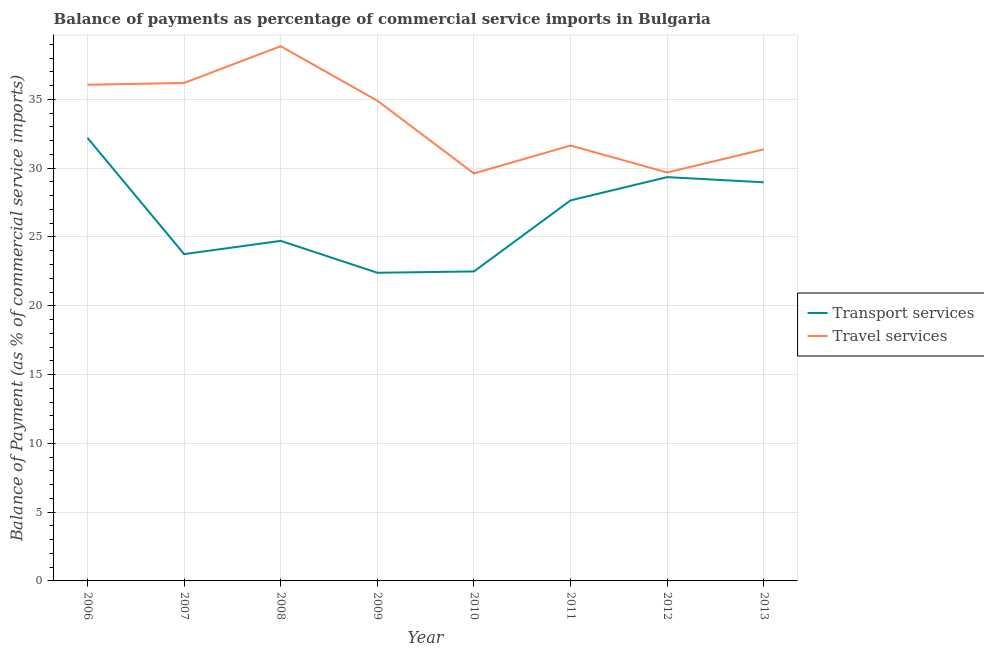How many different coloured lines are there?
Provide a succinct answer. 2. Does the line corresponding to balance of payments of transport services intersect with the line corresponding to balance of payments of travel services?
Your answer should be very brief. No. Is the number of lines equal to the number of legend labels?
Keep it short and to the point. Yes. What is the balance of payments of travel services in 2007?
Make the answer very short. 36.2. Across all years, what is the maximum balance of payments of travel services?
Your answer should be compact. 38.87. Across all years, what is the minimum balance of payments of transport services?
Make the answer very short. 22.4. What is the total balance of payments of travel services in the graph?
Give a very brief answer. 268.36. What is the difference between the balance of payments of travel services in 2007 and that in 2009?
Your answer should be very brief. 1.29. What is the difference between the balance of payments of travel services in 2012 and the balance of payments of transport services in 2006?
Your response must be concise. -2.51. What is the average balance of payments of travel services per year?
Your answer should be very brief. 33.55. In the year 2006, what is the difference between the balance of payments of transport services and balance of payments of travel services?
Your answer should be compact. -3.86. What is the ratio of the balance of payments of travel services in 2006 to that in 2012?
Offer a very short reply. 1.21. Is the balance of payments of travel services in 2007 less than that in 2009?
Provide a short and direct response. No. What is the difference between the highest and the second highest balance of payments of transport services?
Provide a short and direct response. 2.85. What is the difference between the highest and the lowest balance of payments of transport services?
Offer a very short reply. 9.8. Is the sum of the balance of payments of transport services in 2010 and 2012 greater than the maximum balance of payments of travel services across all years?
Keep it short and to the point. Yes. Does the balance of payments of travel services monotonically increase over the years?
Provide a short and direct response. No. How many years are there in the graph?
Your answer should be compact. 8. Are the values on the major ticks of Y-axis written in scientific E-notation?
Your answer should be compact. No. Where does the legend appear in the graph?
Your answer should be very brief. Center right. How are the legend labels stacked?
Your answer should be very brief. Vertical. What is the title of the graph?
Make the answer very short. Balance of payments as percentage of commercial service imports in Bulgaria. What is the label or title of the X-axis?
Your answer should be compact. Year. What is the label or title of the Y-axis?
Your answer should be very brief. Balance of Payment (as % of commercial service imports). What is the Balance of Payment (as % of commercial service imports) in Transport services in 2006?
Give a very brief answer. 32.2. What is the Balance of Payment (as % of commercial service imports) of Travel services in 2006?
Provide a short and direct response. 36.06. What is the Balance of Payment (as % of commercial service imports) of Transport services in 2007?
Your answer should be very brief. 23.75. What is the Balance of Payment (as % of commercial service imports) in Travel services in 2007?
Your response must be concise. 36.2. What is the Balance of Payment (as % of commercial service imports) in Transport services in 2008?
Provide a succinct answer. 24.72. What is the Balance of Payment (as % of commercial service imports) in Travel services in 2008?
Your answer should be very brief. 38.87. What is the Balance of Payment (as % of commercial service imports) of Transport services in 2009?
Offer a very short reply. 22.4. What is the Balance of Payment (as % of commercial service imports) in Travel services in 2009?
Your response must be concise. 34.91. What is the Balance of Payment (as % of commercial service imports) in Transport services in 2010?
Your answer should be very brief. 22.5. What is the Balance of Payment (as % of commercial service imports) of Travel services in 2010?
Your response must be concise. 29.62. What is the Balance of Payment (as % of commercial service imports) in Transport services in 2011?
Make the answer very short. 27.66. What is the Balance of Payment (as % of commercial service imports) in Travel services in 2011?
Your answer should be very brief. 31.65. What is the Balance of Payment (as % of commercial service imports) in Transport services in 2012?
Offer a terse response. 29.35. What is the Balance of Payment (as % of commercial service imports) in Travel services in 2012?
Your answer should be very brief. 29.69. What is the Balance of Payment (as % of commercial service imports) of Transport services in 2013?
Provide a succinct answer. 28.98. What is the Balance of Payment (as % of commercial service imports) in Travel services in 2013?
Make the answer very short. 31.37. Across all years, what is the maximum Balance of Payment (as % of commercial service imports) of Transport services?
Your answer should be compact. 32.2. Across all years, what is the maximum Balance of Payment (as % of commercial service imports) of Travel services?
Make the answer very short. 38.87. Across all years, what is the minimum Balance of Payment (as % of commercial service imports) of Transport services?
Ensure brevity in your answer.  22.4. Across all years, what is the minimum Balance of Payment (as % of commercial service imports) of Travel services?
Offer a very short reply. 29.62. What is the total Balance of Payment (as % of commercial service imports) in Transport services in the graph?
Ensure brevity in your answer.  211.56. What is the total Balance of Payment (as % of commercial service imports) of Travel services in the graph?
Your response must be concise. 268.36. What is the difference between the Balance of Payment (as % of commercial service imports) in Transport services in 2006 and that in 2007?
Your answer should be compact. 8.45. What is the difference between the Balance of Payment (as % of commercial service imports) in Travel services in 2006 and that in 2007?
Offer a terse response. -0.13. What is the difference between the Balance of Payment (as % of commercial service imports) of Transport services in 2006 and that in 2008?
Give a very brief answer. 7.48. What is the difference between the Balance of Payment (as % of commercial service imports) in Travel services in 2006 and that in 2008?
Offer a very short reply. -2.8. What is the difference between the Balance of Payment (as % of commercial service imports) of Transport services in 2006 and that in 2009?
Ensure brevity in your answer.  9.8. What is the difference between the Balance of Payment (as % of commercial service imports) in Travel services in 2006 and that in 2009?
Ensure brevity in your answer.  1.16. What is the difference between the Balance of Payment (as % of commercial service imports) of Transport services in 2006 and that in 2010?
Ensure brevity in your answer.  9.71. What is the difference between the Balance of Payment (as % of commercial service imports) in Travel services in 2006 and that in 2010?
Provide a succinct answer. 6.45. What is the difference between the Balance of Payment (as % of commercial service imports) of Transport services in 2006 and that in 2011?
Give a very brief answer. 4.54. What is the difference between the Balance of Payment (as % of commercial service imports) in Travel services in 2006 and that in 2011?
Make the answer very short. 4.42. What is the difference between the Balance of Payment (as % of commercial service imports) of Transport services in 2006 and that in 2012?
Your response must be concise. 2.85. What is the difference between the Balance of Payment (as % of commercial service imports) in Travel services in 2006 and that in 2012?
Ensure brevity in your answer.  6.37. What is the difference between the Balance of Payment (as % of commercial service imports) in Transport services in 2006 and that in 2013?
Give a very brief answer. 3.23. What is the difference between the Balance of Payment (as % of commercial service imports) in Travel services in 2006 and that in 2013?
Provide a succinct answer. 4.7. What is the difference between the Balance of Payment (as % of commercial service imports) in Transport services in 2007 and that in 2008?
Ensure brevity in your answer.  -0.96. What is the difference between the Balance of Payment (as % of commercial service imports) of Travel services in 2007 and that in 2008?
Offer a terse response. -2.67. What is the difference between the Balance of Payment (as % of commercial service imports) of Transport services in 2007 and that in 2009?
Give a very brief answer. 1.35. What is the difference between the Balance of Payment (as % of commercial service imports) in Travel services in 2007 and that in 2009?
Provide a short and direct response. 1.29. What is the difference between the Balance of Payment (as % of commercial service imports) of Transport services in 2007 and that in 2010?
Your answer should be very brief. 1.26. What is the difference between the Balance of Payment (as % of commercial service imports) of Travel services in 2007 and that in 2010?
Give a very brief answer. 6.58. What is the difference between the Balance of Payment (as % of commercial service imports) of Transport services in 2007 and that in 2011?
Keep it short and to the point. -3.91. What is the difference between the Balance of Payment (as % of commercial service imports) of Travel services in 2007 and that in 2011?
Ensure brevity in your answer.  4.55. What is the difference between the Balance of Payment (as % of commercial service imports) in Transport services in 2007 and that in 2012?
Offer a terse response. -5.6. What is the difference between the Balance of Payment (as % of commercial service imports) in Travel services in 2007 and that in 2012?
Provide a succinct answer. 6.51. What is the difference between the Balance of Payment (as % of commercial service imports) in Transport services in 2007 and that in 2013?
Provide a short and direct response. -5.22. What is the difference between the Balance of Payment (as % of commercial service imports) of Travel services in 2007 and that in 2013?
Make the answer very short. 4.83. What is the difference between the Balance of Payment (as % of commercial service imports) of Transport services in 2008 and that in 2009?
Give a very brief answer. 2.32. What is the difference between the Balance of Payment (as % of commercial service imports) of Travel services in 2008 and that in 2009?
Provide a succinct answer. 3.96. What is the difference between the Balance of Payment (as % of commercial service imports) of Transport services in 2008 and that in 2010?
Your response must be concise. 2.22. What is the difference between the Balance of Payment (as % of commercial service imports) of Travel services in 2008 and that in 2010?
Your answer should be very brief. 9.25. What is the difference between the Balance of Payment (as % of commercial service imports) in Transport services in 2008 and that in 2011?
Provide a short and direct response. -2.94. What is the difference between the Balance of Payment (as % of commercial service imports) in Travel services in 2008 and that in 2011?
Provide a succinct answer. 7.22. What is the difference between the Balance of Payment (as % of commercial service imports) of Transport services in 2008 and that in 2012?
Your response must be concise. -4.63. What is the difference between the Balance of Payment (as % of commercial service imports) of Travel services in 2008 and that in 2012?
Your answer should be compact. 9.18. What is the difference between the Balance of Payment (as % of commercial service imports) in Transport services in 2008 and that in 2013?
Your response must be concise. -4.26. What is the difference between the Balance of Payment (as % of commercial service imports) in Travel services in 2008 and that in 2013?
Make the answer very short. 7.5. What is the difference between the Balance of Payment (as % of commercial service imports) of Transport services in 2009 and that in 2010?
Your response must be concise. -0.1. What is the difference between the Balance of Payment (as % of commercial service imports) of Travel services in 2009 and that in 2010?
Your answer should be compact. 5.29. What is the difference between the Balance of Payment (as % of commercial service imports) in Transport services in 2009 and that in 2011?
Make the answer very short. -5.26. What is the difference between the Balance of Payment (as % of commercial service imports) in Travel services in 2009 and that in 2011?
Your answer should be compact. 3.26. What is the difference between the Balance of Payment (as % of commercial service imports) in Transport services in 2009 and that in 2012?
Offer a terse response. -6.95. What is the difference between the Balance of Payment (as % of commercial service imports) in Travel services in 2009 and that in 2012?
Your response must be concise. 5.22. What is the difference between the Balance of Payment (as % of commercial service imports) of Transport services in 2009 and that in 2013?
Your answer should be very brief. -6.58. What is the difference between the Balance of Payment (as % of commercial service imports) of Travel services in 2009 and that in 2013?
Your answer should be compact. 3.54. What is the difference between the Balance of Payment (as % of commercial service imports) in Transport services in 2010 and that in 2011?
Your answer should be compact. -5.17. What is the difference between the Balance of Payment (as % of commercial service imports) of Travel services in 2010 and that in 2011?
Offer a terse response. -2.03. What is the difference between the Balance of Payment (as % of commercial service imports) in Transport services in 2010 and that in 2012?
Offer a very short reply. -6.86. What is the difference between the Balance of Payment (as % of commercial service imports) in Travel services in 2010 and that in 2012?
Keep it short and to the point. -0.07. What is the difference between the Balance of Payment (as % of commercial service imports) in Transport services in 2010 and that in 2013?
Your answer should be compact. -6.48. What is the difference between the Balance of Payment (as % of commercial service imports) in Travel services in 2010 and that in 2013?
Your answer should be compact. -1.75. What is the difference between the Balance of Payment (as % of commercial service imports) of Transport services in 2011 and that in 2012?
Provide a short and direct response. -1.69. What is the difference between the Balance of Payment (as % of commercial service imports) of Travel services in 2011 and that in 2012?
Offer a very short reply. 1.96. What is the difference between the Balance of Payment (as % of commercial service imports) in Transport services in 2011 and that in 2013?
Your response must be concise. -1.31. What is the difference between the Balance of Payment (as % of commercial service imports) in Travel services in 2011 and that in 2013?
Give a very brief answer. 0.28. What is the difference between the Balance of Payment (as % of commercial service imports) in Transport services in 2012 and that in 2013?
Give a very brief answer. 0.38. What is the difference between the Balance of Payment (as % of commercial service imports) of Travel services in 2012 and that in 2013?
Your answer should be very brief. -1.68. What is the difference between the Balance of Payment (as % of commercial service imports) of Transport services in 2006 and the Balance of Payment (as % of commercial service imports) of Travel services in 2007?
Provide a short and direct response. -3.99. What is the difference between the Balance of Payment (as % of commercial service imports) in Transport services in 2006 and the Balance of Payment (as % of commercial service imports) in Travel services in 2008?
Your response must be concise. -6.67. What is the difference between the Balance of Payment (as % of commercial service imports) of Transport services in 2006 and the Balance of Payment (as % of commercial service imports) of Travel services in 2009?
Give a very brief answer. -2.7. What is the difference between the Balance of Payment (as % of commercial service imports) in Transport services in 2006 and the Balance of Payment (as % of commercial service imports) in Travel services in 2010?
Your answer should be compact. 2.58. What is the difference between the Balance of Payment (as % of commercial service imports) in Transport services in 2006 and the Balance of Payment (as % of commercial service imports) in Travel services in 2011?
Offer a terse response. 0.56. What is the difference between the Balance of Payment (as % of commercial service imports) of Transport services in 2006 and the Balance of Payment (as % of commercial service imports) of Travel services in 2012?
Give a very brief answer. 2.51. What is the difference between the Balance of Payment (as % of commercial service imports) in Transport services in 2007 and the Balance of Payment (as % of commercial service imports) in Travel services in 2008?
Your answer should be very brief. -15.11. What is the difference between the Balance of Payment (as % of commercial service imports) of Transport services in 2007 and the Balance of Payment (as % of commercial service imports) of Travel services in 2009?
Provide a short and direct response. -11.15. What is the difference between the Balance of Payment (as % of commercial service imports) of Transport services in 2007 and the Balance of Payment (as % of commercial service imports) of Travel services in 2010?
Ensure brevity in your answer.  -5.86. What is the difference between the Balance of Payment (as % of commercial service imports) of Transport services in 2007 and the Balance of Payment (as % of commercial service imports) of Travel services in 2011?
Your response must be concise. -7.89. What is the difference between the Balance of Payment (as % of commercial service imports) in Transport services in 2007 and the Balance of Payment (as % of commercial service imports) in Travel services in 2012?
Provide a succinct answer. -5.94. What is the difference between the Balance of Payment (as % of commercial service imports) of Transport services in 2007 and the Balance of Payment (as % of commercial service imports) of Travel services in 2013?
Make the answer very short. -7.62. What is the difference between the Balance of Payment (as % of commercial service imports) in Transport services in 2008 and the Balance of Payment (as % of commercial service imports) in Travel services in 2009?
Offer a terse response. -10.19. What is the difference between the Balance of Payment (as % of commercial service imports) in Transport services in 2008 and the Balance of Payment (as % of commercial service imports) in Travel services in 2010?
Make the answer very short. -4.9. What is the difference between the Balance of Payment (as % of commercial service imports) of Transport services in 2008 and the Balance of Payment (as % of commercial service imports) of Travel services in 2011?
Your response must be concise. -6.93. What is the difference between the Balance of Payment (as % of commercial service imports) in Transport services in 2008 and the Balance of Payment (as % of commercial service imports) in Travel services in 2012?
Offer a very short reply. -4.97. What is the difference between the Balance of Payment (as % of commercial service imports) in Transport services in 2008 and the Balance of Payment (as % of commercial service imports) in Travel services in 2013?
Make the answer very short. -6.65. What is the difference between the Balance of Payment (as % of commercial service imports) in Transport services in 2009 and the Balance of Payment (as % of commercial service imports) in Travel services in 2010?
Your response must be concise. -7.22. What is the difference between the Balance of Payment (as % of commercial service imports) in Transport services in 2009 and the Balance of Payment (as % of commercial service imports) in Travel services in 2011?
Keep it short and to the point. -9.25. What is the difference between the Balance of Payment (as % of commercial service imports) of Transport services in 2009 and the Balance of Payment (as % of commercial service imports) of Travel services in 2012?
Ensure brevity in your answer.  -7.29. What is the difference between the Balance of Payment (as % of commercial service imports) in Transport services in 2009 and the Balance of Payment (as % of commercial service imports) in Travel services in 2013?
Keep it short and to the point. -8.97. What is the difference between the Balance of Payment (as % of commercial service imports) in Transport services in 2010 and the Balance of Payment (as % of commercial service imports) in Travel services in 2011?
Your answer should be very brief. -9.15. What is the difference between the Balance of Payment (as % of commercial service imports) of Transport services in 2010 and the Balance of Payment (as % of commercial service imports) of Travel services in 2012?
Ensure brevity in your answer.  -7.19. What is the difference between the Balance of Payment (as % of commercial service imports) in Transport services in 2010 and the Balance of Payment (as % of commercial service imports) in Travel services in 2013?
Your answer should be very brief. -8.87. What is the difference between the Balance of Payment (as % of commercial service imports) of Transport services in 2011 and the Balance of Payment (as % of commercial service imports) of Travel services in 2012?
Give a very brief answer. -2.03. What is the difference between the Balance of Payment (as % of commercial service imports) in Transport services in 2011 and the Balance of Payment (as % of commercial service imports) in Travel services in 2013?
Give a very brief answer. -3.71. What is the difference between the Balance of Payment (as % of commercial service imports) of Transport services in 2012 and the Balance of Payment (as % of commercial service imports) of Travel services in 2013?
Give a very brief answer. -2.02. What is the average Balance of Payment (as % of commercial service imports) in Transport services per year?
Offer a very short reply. 26.45. What is the average Balance of Payment (as % of commercial service imports) of Travel services per year?
Your response must be concise. 33.55. In the year 2006, what is the difference between the Balance of Payment (as % of commercial service imports) in Transport services and Balance of Payment (as % of commercial service imports) in Travel services?
Your response must be concise. -3.86. In the year 2007, what is the difference between the Balance of Payment (as % of commercial service imports) of Transport services and Balance of Payment (as % of commercial service imports) of Travel services?
Offer a terse response. -12.44. In the year 2008, what is the difference between the Balance of Payment (as % of commercial service imports) in Transport services and Balance of Payment (as % of commercial service imports) in Travel services?
Your response must be concise. -14.15. In the year 2009, what is the difference between the Balance of Payment (as % of commercial service imports) in Transport services and Balance of Payment (as % of commercial service imports) in Travel services?
Your response must be concise. -12.51. In the year 2010, what is the difference between the Balance of Payment (as % of commercial service imports) of Transport services and Balance of Payment (as % of commercial service imports) of Travel services?
Ensure brevity in your answer.  -7.12. In the year 2011, what is the difference between the Balance of Payment (as % of commercial service imports) in Transport services and Balance of Payment (as % of commercial service imports) in Travel services?
Keep it short and to the point. -3.99. In the year 2012, what is the difference between the Balance of Payment (as % of commercial service imports) in Transport services and Balance of Payment (as % of commercial service imports) in Travel services?
Make the answer very short. -0.34. In the year 2013, what is the difference between the Balance of Payment (as % of commercial service imports) of Transport services and Balance of Payment (as % of commercial service imports) of Travel services?
Your answer should be compact. -2.39. What is the ratio of the Balance of Payment (as % of commercial service imports) in Transport services in 2006 to that in 2007?
Offer a terse response. 1.36. What is the ratio of the Balance of Payment (as % of commercial service imports) in Travel services in 2006 to that in 2007?
Provide a succinct answer. 1. What is the ratio of the Balance of Payment (as % of commercial service imports) of Transport services in 2006 to that in 2008?
Provide a short and direct response. 1.3. What is the ratio of the Balance of Payment (as % of commercial service imports) in Travel services in 2006 to that in 2008?
Provide a short and direct response. 0.93. What is the ratio of the Balance of Payment (as % of commercial service imports) of Transport services in 2006 to that in 2009?
Your answer should be very brief. 1.44. What is the ratio of the Balance of Payment (as % of commercial service imports) in Travel services in 2006 to that in 2009?
Your response must be concise. 1.03. What is the ratio of the Balance of Payment (as % of commercial service imports) of Transport services in 2006 to that in 2010?
Provide a succinct answer. 1.43. What is the ratio of the Balance of Payment (as % of commercial service imports) in Travel services in 2006 to that in 2010?
Your answer should be very brief. 1.22. What is the ratio of the Balance of Payment (as % of commercial service imports) in Transport services in 2006 to that in 2011?
Provide a short and direct response. 1.16. What is the ratio of the Balance of Payment (as % of commercial service imports) in Travel services in 2006 to that in 2011?
Keep it short and to the point. 1.14. What is the ratio of the Balance of Payment (as % of commercial service imports) in Transport services in 2006 to that in 2012?
Give a very brief answer. 1.1. What is the ratio of the Balance of Payment (as % of commercial service imports) of Travel services in 2006 to that in 2012?
Keep it short and to the point. 1.21. What is the ratio of the Balance of Payment (as % of commercial service imports) of Transport services in 2006 to that in 2013?
Give a very brief answer. 1.11. What is the ratio of the Balance of Payment (as % of commercial service imports) in Travel services in 2006 to that in 2013?
Keep it short and to the point. 1.15. What is the ratio of the Balance of Payment (as % of commercial service imports) in Transport services in 2007 to that in 2008?
Offer a terse response. 0.96. What is the ratio of the Balance of Payment (as % of commercial service imports) in Travel services in 2007 to that in 2008?
Ensure brevity in your answer.  0.93. What is the ratio of the Balance of Payment (as % of commercial service imports) of Transport services in 2007 to that in 2009?
Offer a very short reply. 1.06. What is the ratio of the Balance of Payment (as % of commercial service imports) in Transport services in 2007 to that in 2010?
Your answer should be compact. 1.06. What is the ratio of the Balance of Payment (as % of commercial service imports) in Travel services in 2007 to that in 2010?
Give a very brief answer. 1.22. What is the ratio of the Balance of Payment (as % of commercial service imports) of Transport services in 2007 to that in 2011?
Your response must be concise. 0.86. What is the ratio of the Balance of Payment (as % of commercial service imports) in Travel services in 2007 to that in 2011?
Provide a short and direct response. 1.14. What is the ratio of the Balance of Payment (as % of commercial service imports) in Transport services in 2007 to that in 2012?
Provide a short and direct response. 0.81. What is the ratio of the Balance of Payment (as % of commercial service imports) in Travel services in 2007 to that in 2012?
Keep it short and to the point. 1.22. What is the ratio of the Balance of Payment (as % of commercial service imports) of Transport services in 2007 to that in 2013?
Offer a very short reply. 0.82. What is the ratio of the Balance of Payment (as % of commercial service imports) of Travel services in 2007 to that in 2013?
Give a very brief answer. 1.15. What is the ratio of the Balance of Payment (as % of commercial service imports) in Transport services in 2008 to that in 2009?
Your response must be concise. 1.1. What is the ratio of the Balance of Payment (as % of commercial service imports) of Travel services in 2008 to that in 2009?
Provide a succinct answer. 1.11. What is the ratio of the Balance of Payment (as % of commercial service imports) of Transport services in 2008 to that in 2010?
Your response must be concise. 1.1. What is the ratio of the Balance of Payment (as % of commercial service imports) in Travel services in 2008 to that in 2010?
Offer a very short reply. 1.31. What is the ratio of the Balance of Payment (as % of commercial service imports) of Transport services in 2008 to that in 2011?
Ensure brevity in your answer.  0.89. What is the ratio of the Balance of Payment (as % of commercial service imports) in Travel services in 2008 to that in 2011?
Provide a succinct answer. 1.23. What is the ratio of the Balance of Payment (as % of commercial service imports) of Transport services in 2008 to that in 2012?
Give a very brief answer. 0.84. What is the ratio of the Balance of Payment (as % of commercial service imports) of Travel services in 2008 to that in 2012?
Offer a terse response. 1.31. What is the ratio of the Balance of Payment (as % of commercial service imports) in Transport services in 2008 to that in 2013?
Your answer should be compact. 0.85. What is the ratio of the Balance of Payment (as % of commercial service imports) in Travel services in 2008 to that in 2013?
Your answer should be very brief. 1.24. What is the ratio of the Balance of Payment (as % of commercial service imports) of Travel services in 2009 to that in 2010?
Keep it short and to the point. 1.18. What is the ratio of the Balance of Payment (as % of commercial service imports) of Transport services in 2009 to that in 2011?
Offer a terse response. 0.81. What is the ratio of the Balance of Payment (as % of commercial service imports) of Travel services in 2009 to that in 2011?
Provide a succinct answer. 1.1. What is the ratio of the Balance of Payment (as % of commercial service imports) of Transport services in 2009 to that in 2012?
Keep it short and to the point. 0.76. What is the ratio of the Balance of Payment (as % of commercial service imports) of Travel services in 2009 to that in 2012?
Offer a very short reply. 1.18. What is the ratio of the Balance of Payment (as % of commercial service imports) of Transport services in 2009 to that in 2013?
Give a very brief answer. 0.77. What is the ratio of the Balance of Payment (as % of commercial service imports) of Travel services in 2009 to that in 2013?
Offer a very short reply. 1.11. What is the ratio of the Balance of Payment (as % of commercial service imports) of Transport services in 2010 to that in 2011?
Offer a very short reply. 0.81. What is the ratio of the Balance of Payment (as % of commercial service imports) in Travel services in 2010 to that in 2011?
Give a very brief answer. 0.94. What is the ratio of the Balance of Payment (as % of commercial service imports) of Transport services in 2010 to that in 2012?
Your answer should be compact. 0.77. What is the ratio of the Balance of Payment (as % of commercial service imports) of Transport services in 2010 to that in 2013?
Provide a succinct answer. 0.78. What is the ratio of the Balance of Payment (as % of commercial service imports) of Travel services in 2010 to that in 2013?
Offer a very short reply. 0.94. What is the ratio of the Balance of Payment (as % of commercial service imports) in Transport services in 2011 to that in 2012?
Provide a short and direct response. 0.94. What is the ratio of the Balance of Payment (as % of commercial service imports) in Travel services in 2011 to that in 2012?
Offer a terse response. 1.07. What is the ratio of the Balance of Payment (as % of commercial service imports) in Transport services in 2011 to that in 2013?
Your answer should be very brief. 0.95. What is the ratio of the Balance of Payment (as % of commercial service imports) of Travel services in 2011 to that in 2013?
Your response must be concise. 1.01. What is the ratio of the Balance of Payment (as % of commercial service imports) in Transport services in 2012 to that in 2013?
Give a very brief answer. 1.01. What is the ratio of the Balance of Payment (as % of commercial service imports) in Travel services in 2012 to that in 2013?
Your answer should be very brief. 0.95. What is the difference between the highest and the second highest Balance of Payment (as % of commercial service imports) of Transport services?
Offer a very short reply. 2.85. What is the difference between the highest and the second highest Balance of Payment (as % of commercial service imports) in Travel services?
Give a very brief answer. 2.67. What is the difference between the highest and the lowest Balance of Payment (as % of commercial service imports) of Transport services?
Offer a terse response. 9.8. What is the difference between the highest and the lowest Balance of Payment (as % of commercial service imports) in Travel services?
Provide a short and direct response. 9.25. 